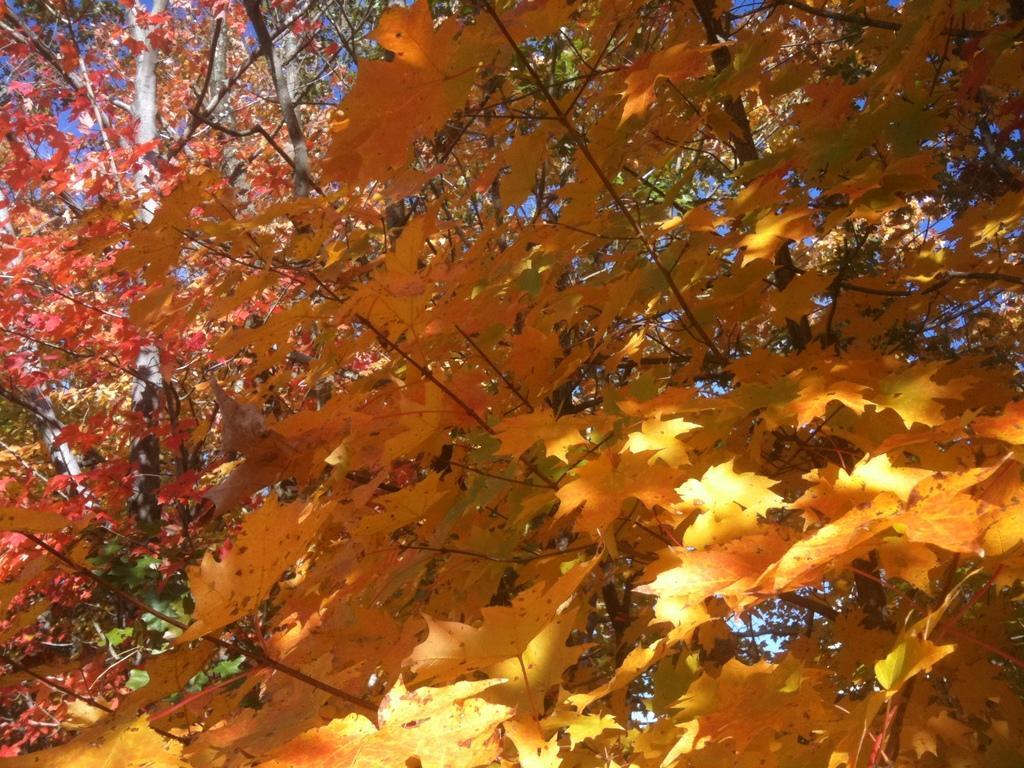In one or two sentences, can you explain what this image depicts? In this image we can see trees and sky in the background. 